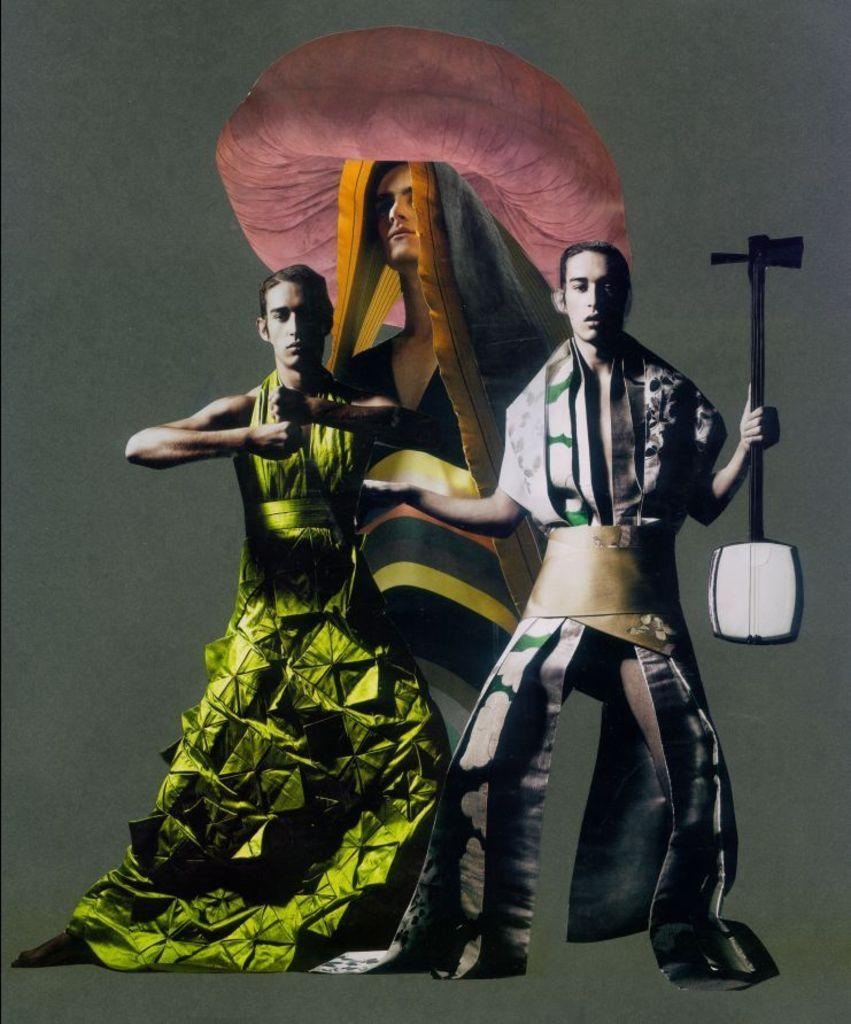How many people are in the image? There are two men in the image. What are the men doing in the image? The men are standing on a surface. What are the men wearing? The men are wearing costumes. What is one of the men holding? One of the men is holding a tool. What can be seen in the background of the image? There is a picture of a person on a wall in the background. What type of property do the giants own in the image? There are no giants present in the image, and therefore no property ownership can be determined. How many squares are visible in the image? There is no mention of squares in the image, so it is impossible to determine their presence or quantity. 